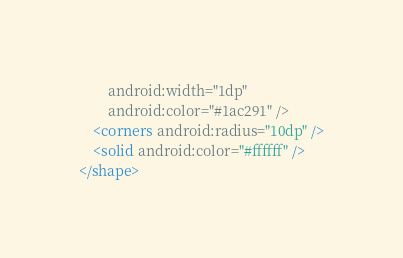<code> <loc_0><loc_0><loc_500><loc_500><_XML_>        android:width="1dp"
        android:color="#1ac291" />
    <corners android:radius="10dp" />
    <solid android:color="#ffffff" />
</shape></code> 